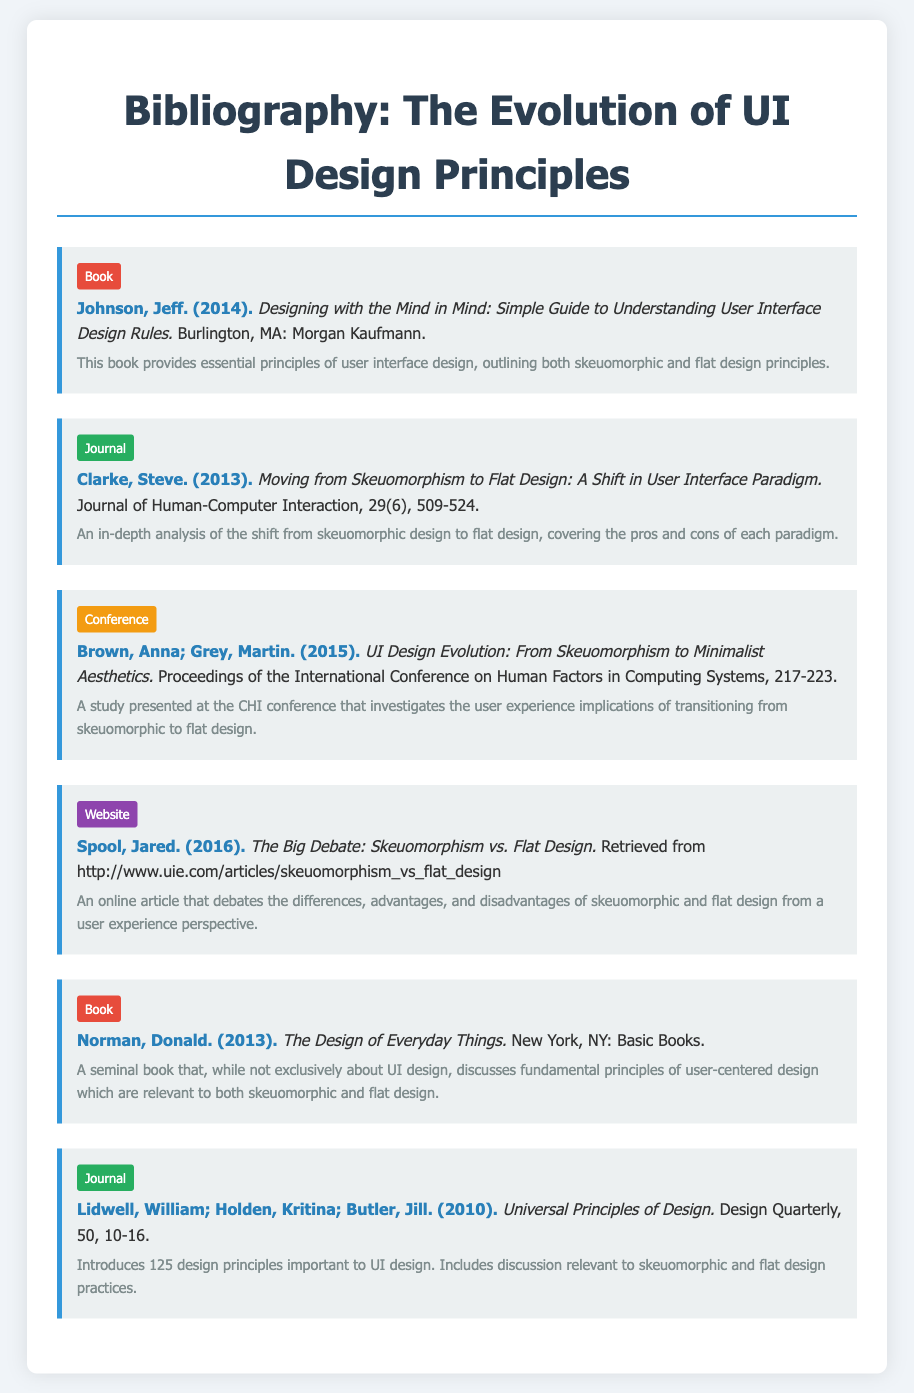What is the title of Jeff Johnson's book? The title, as stated in the entry, is "Designing with the Mind in Mind: Simple Guide to Understanding User Interface Design Rules."
Answer: Designing with the Mind in Mind: Simple Guide to Understanding User Interface Design Rules Who are the authors of the conference paper? The authors listed in the entry are Anna Brown and Martin Grey.
Answer: Anna Brown; Martin Grey What year was the journal article by Steve Clarke published? The publication year, as mentioned in the entry, is 2013.
Answer: 2013 Which design principles are discussed in the book by Donald Norman? The book discusses fundamental principles of user-centered design.
Answer: User-centered design What type of document is Jared Spool's article? The type of document is classified as a website according to the entry.
Answer: Website How many principles are introduced in "Universal Principles of Design"? The number of design principles introduced is 125.
Answer: 125 What is the main focus of Clarke's journal article? The main focus is on the shift from skeuomorphic design to flat design.
Answer: Shift from skeuomorphic to flat design Which publication discusses both skeuomorphic and flat design practices? The journal article by William Lidwell, Kritina Holden, and Jill Butler covers this topic.
Answer: Universal Principles of Design 